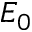<formula> <loc_0><loc_0><loc_500><loc_500>E _ { 0 }</formula> 